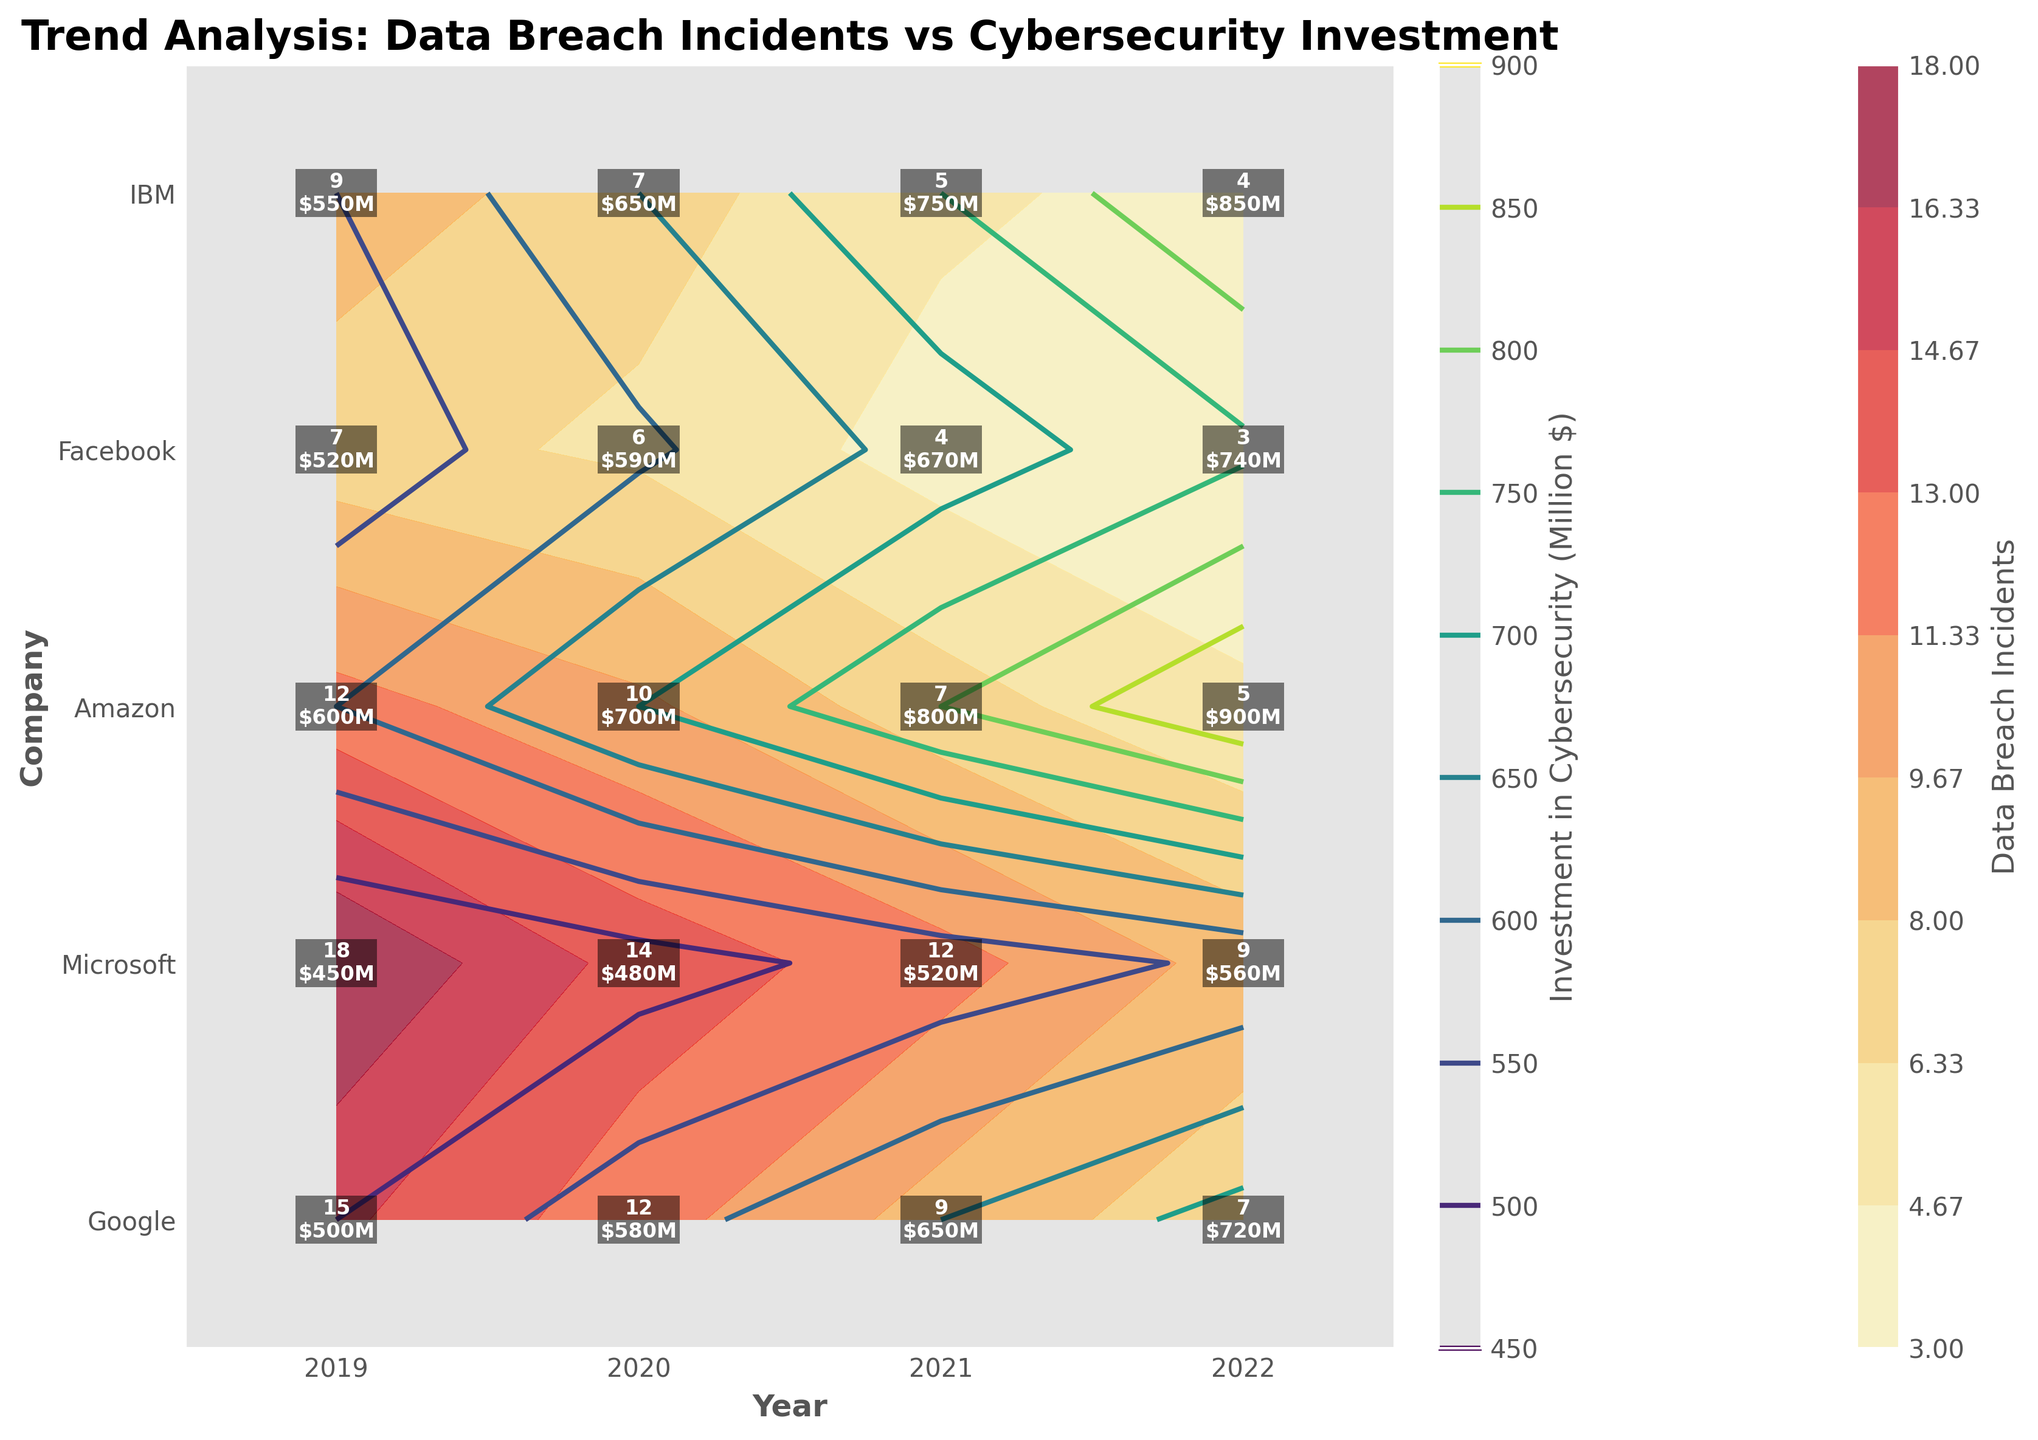What is the title of the plot? The title is usually located at the top of a plot, and it provides a summary of what the plot is about. In this case, the plot has a title that describes its content.
Answer: Trend Analysis: Data Breach Incidents vs Cybersecurity Investment Which company had the highest number of data breach incidents in 2022? First, locate the 2022 column on the x-axis, and then find the company with the darkest yellow-to-red shade, since data breach incidents use the 'YlOrRd' colormap. The text labels can also help in identifying the exact number.
Answer: Facebook How does the number of data breach incidents for Google change from 2019 to 2022? Locate Google on the y-axis and follow the years from 2019 to 2022 on the x-axis. Note the data breach incidents displayed in the labels or the darkness of the color. You can see a reduction in incidents over time.
Answer: Decreases from 12 to 5 Which year did IBM reach the highest investment in cybersecurity? Find IBM on the y-axis and look for the text labels indicating investment figures. The contour lines with darker shades (green in 'viridis') will help identify higher investment levels.
Answer: 2022 What is the trend of data breach incidents for Microsoft over the years? Identify Microsoft on the y-axis and observe each year from 2019 to 2022 on the x-axis. Note the numbers or color intensity related to data breach incidents shown in the plot.
Answer: Decreasing Compare the data breach incidents between Amazon and Facebook in 2020. Locate the year 2020 on the x-axis, then find the data for Amazon and Facebook on the y-axis. Compare the numbers or the color levels for these two companies.
Answer: Amazon: 12, Facebook: 14 What is the difference in cybersecurity investment between 2019 and 2020 for Google? Locate Google on the y-axis and compare the investment values for 2019 and 2020 on the x-axis. Subtract the 2019 value from the 2020 value.
Answer: 100 million dollars Which company had the lowest number of data breach incidents in 2021? Look at the 2021 column and find the company with the lightest yellow-to-red shade, indicating fewer incidents. Confirm by reviewing the text labels.
Answer: IBM What is the general relationship between data breach incidents and cybersecurity investment observed in the plot? Review the contours and labels, noting that as cybersecurity investment increases (fewer incidents), there's generally a downtrend in incidents. Companies with higher investments show fewer incidents over time.
Answer: Higher investment, fewer incidents Which company showed the most significant decrease in data breach incidents from 2019 to 2022? For each company, observe the change in incidents from 2019 to 2022. IBM shows the most drastic change in color intensity and label numbers, going from 7 to 3 incidents.
Answer: IBM 